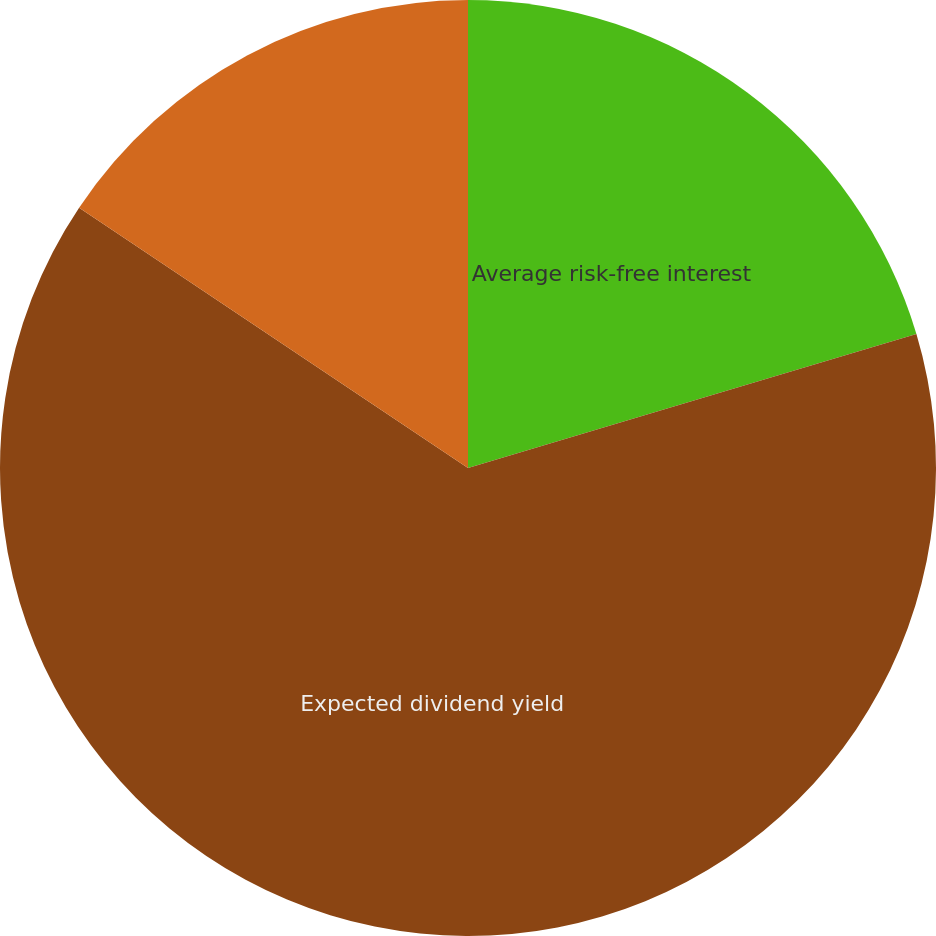Convert chart. <chart><loc_0><loc_0><loc_500><loc_500><pie_chart><fcel>Average risk-free interest<fcel>Expected dividend yield<fcel>Expected volatility (Rockwell<nl><fcel>20.38%<fcel>64.01%<fcel>15.61%<nl></chart> 